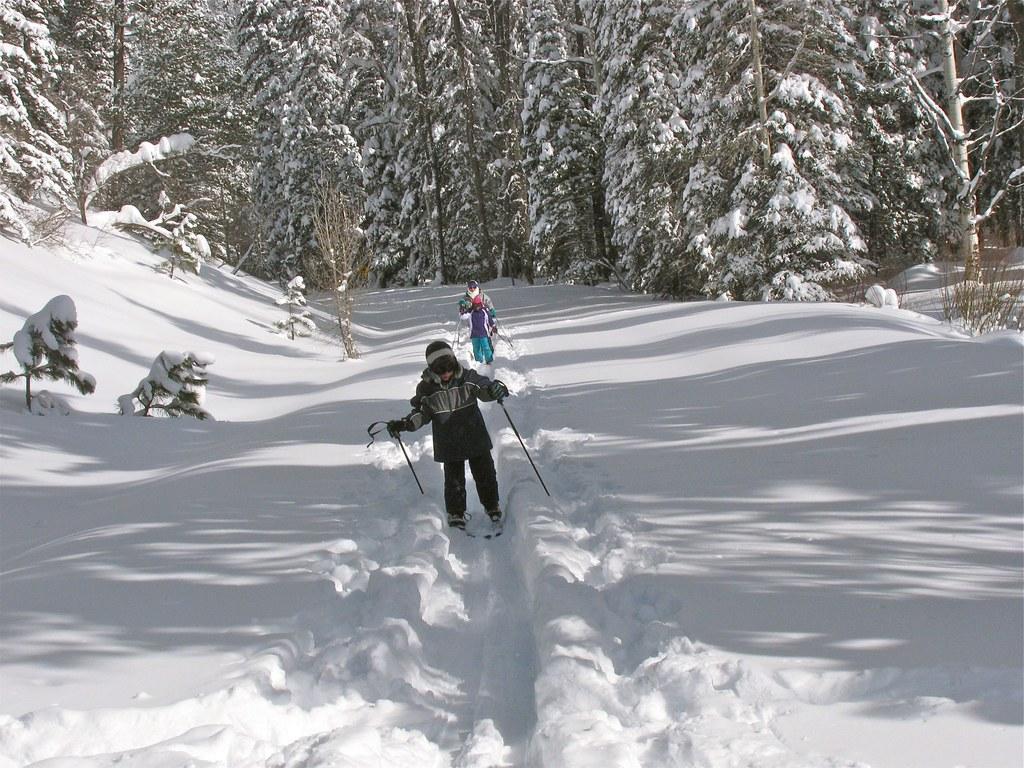In one or two sentences, can you explain what this image depicts? In this image there are two persons, skating on a snow land wearing skating boards and holding sticks in their hands, in the background there are trees that are covered with snow. 